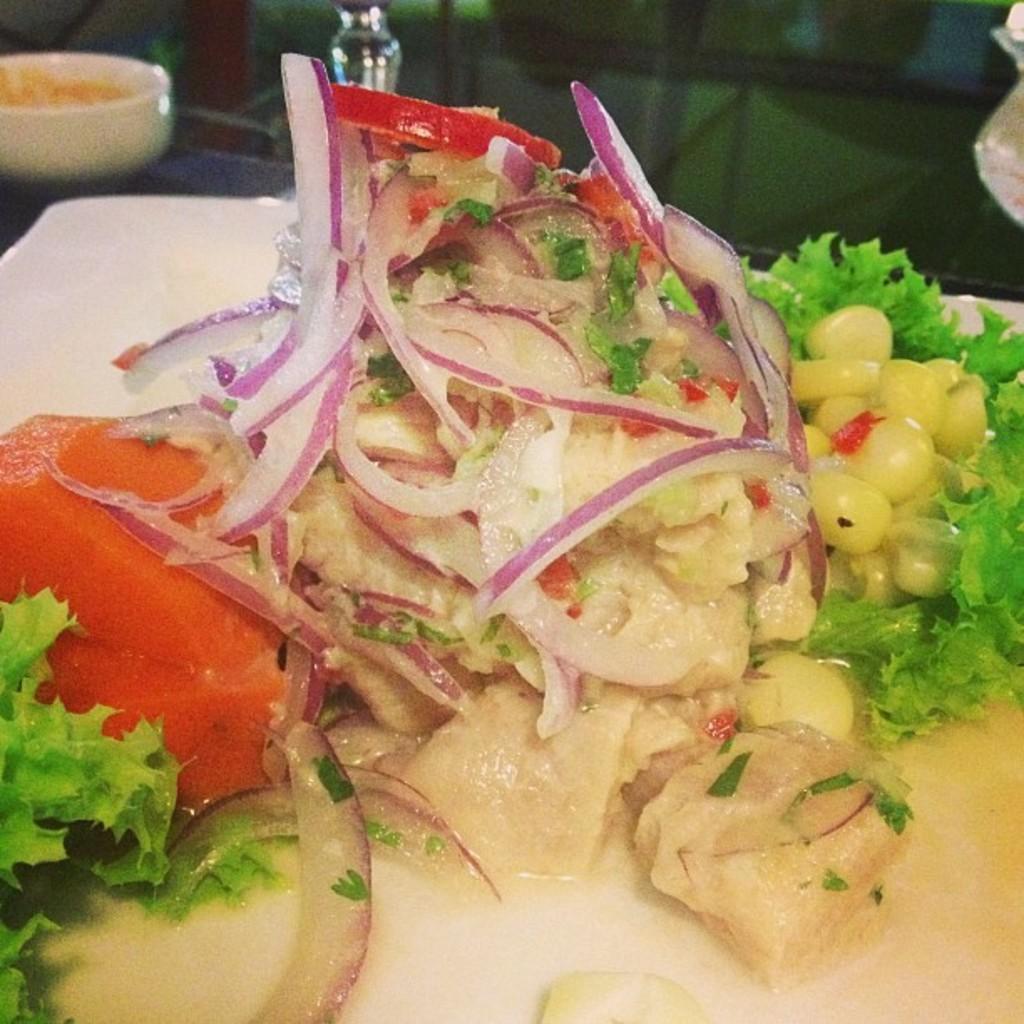In one or two sentences, can you explain what this image depicts? In the center of the image a plate of food item is present on the table. At the top left corner a bowl of food item is there. 